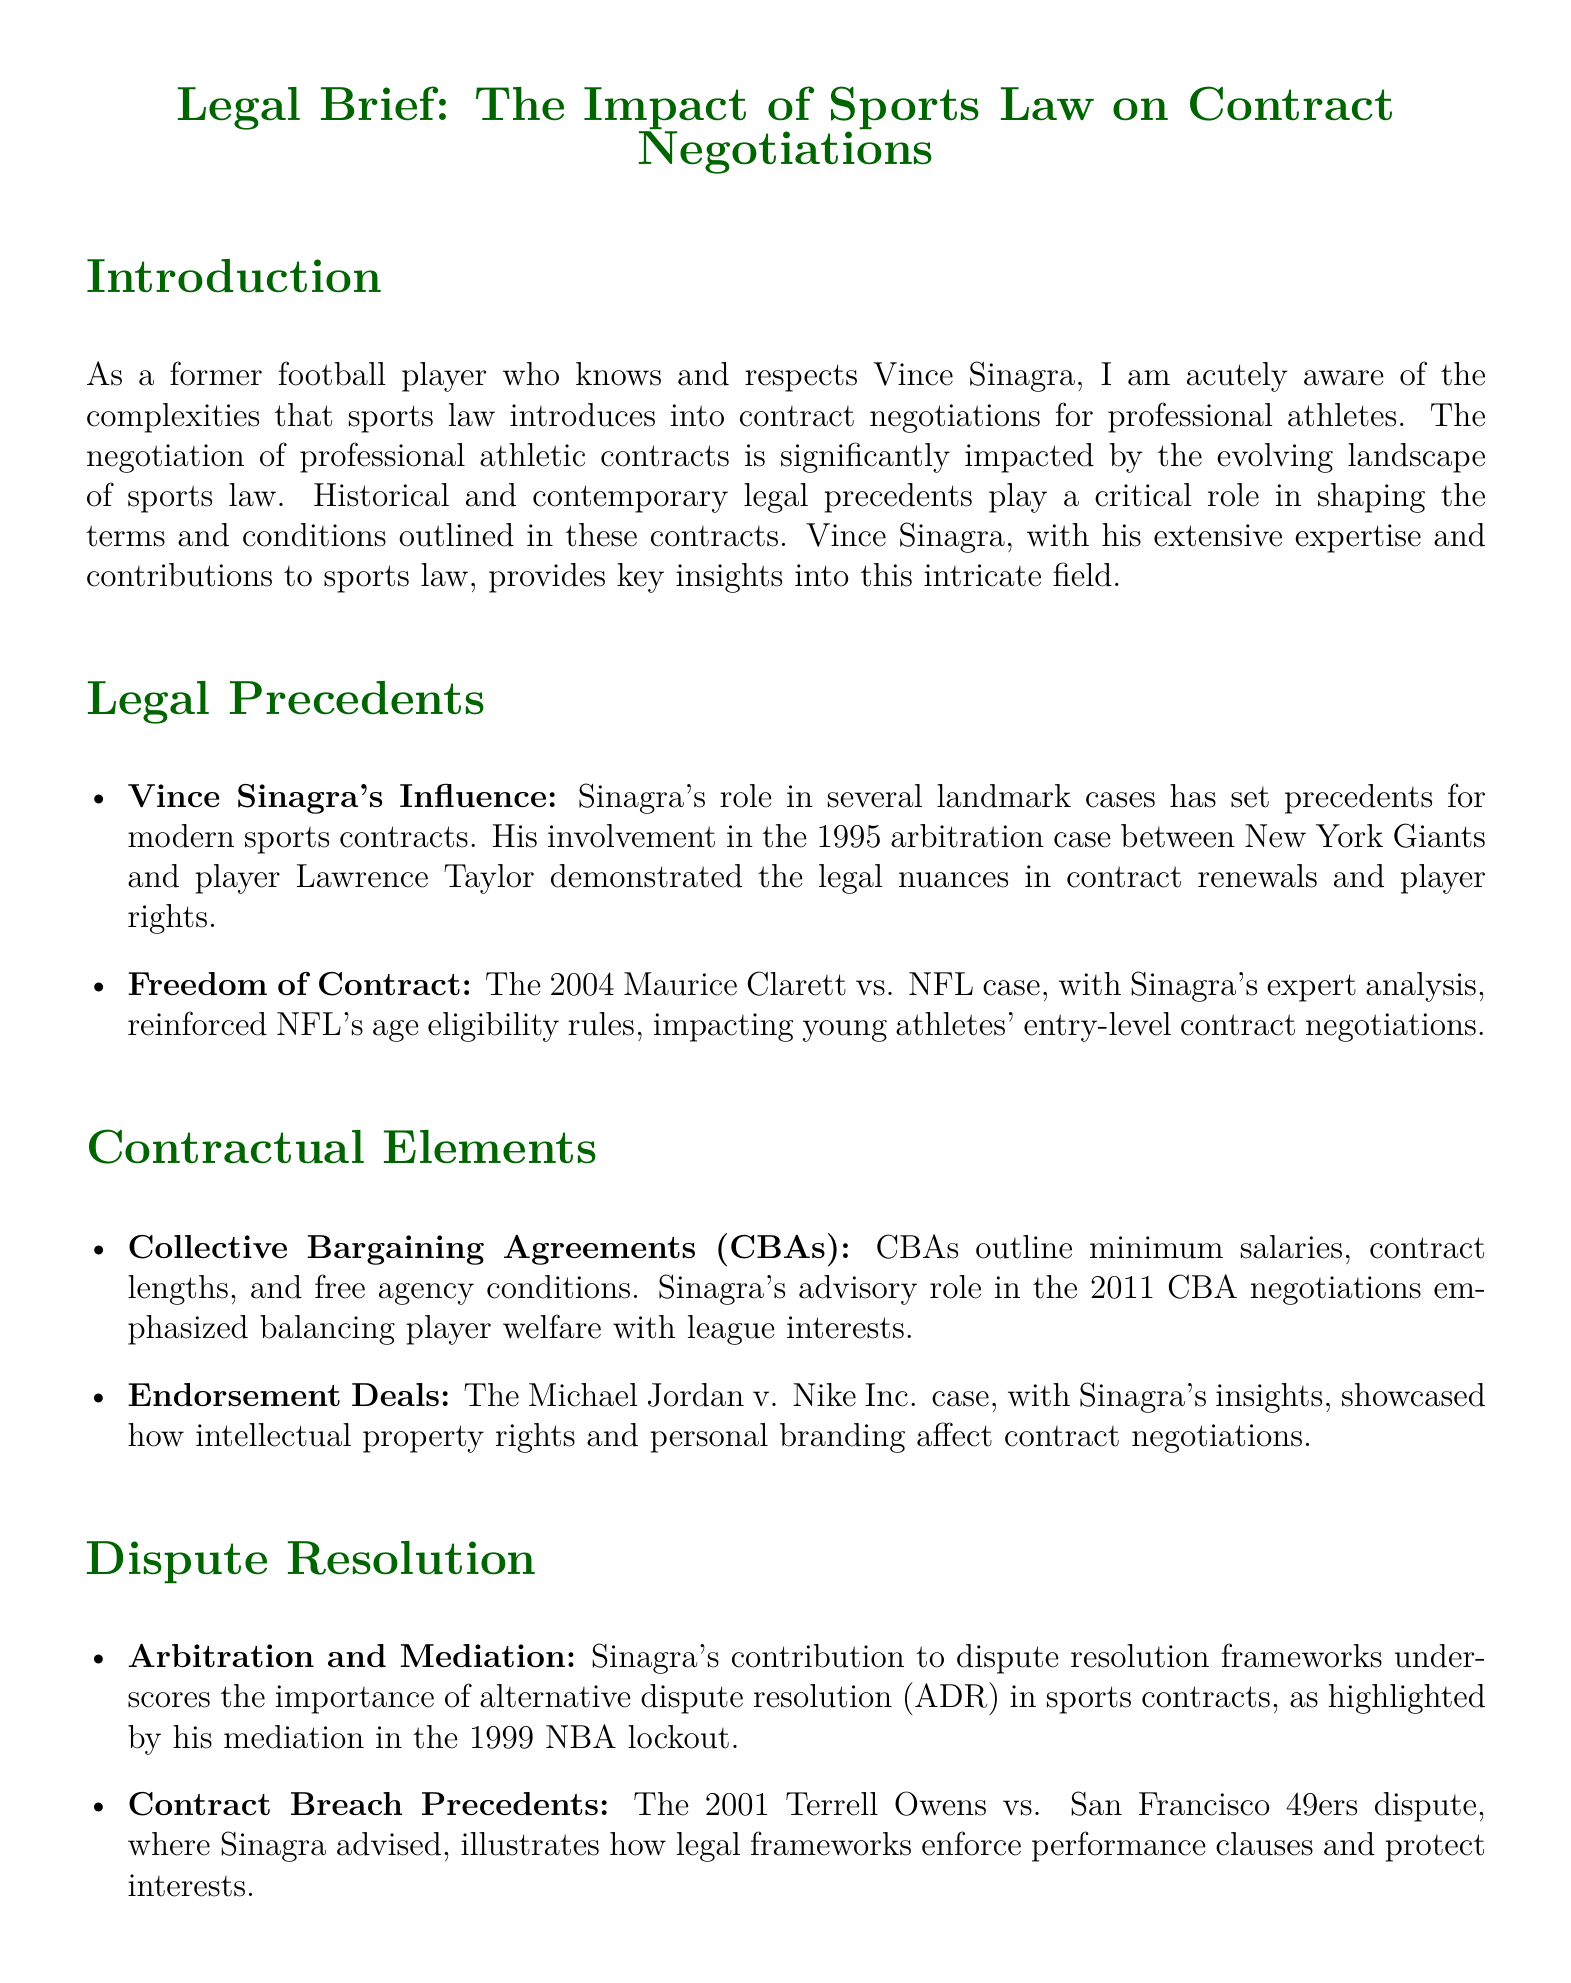What is the title of the document? The title is presented at the top of the document, clearly indicating its subject matter related to sports law.
Answer: Legal Brief: The Impact of Sports Law on Contract Negotiations Who was involved in the 1995 arbitration case? The document states that the case involved the New York Giants and player Lawrence Taylor, highlighting the legal nuances in contract renewals.
Answer: Lawrence Taylor What role did Vince Sinagra play in the 2011 CBA negotiations? The document outlines Sinagra's role as an advisor, emphasizing the balance between player welfare and league interests during negotiations.
Answer: Advisor Which case reinforced NFL's age eligibility rules? The document discusses a specific legal case that played a crucial role in shaping age eligibility for NFL contracts.
Answer: Maurice Clarett vs. NFL What was highlighted by Sinagra's mediation in the 1999 NBA lockout? The document notes the significance of alternative dispute resolution mechanisms in sports contracts.
Answer: Importance of ADR What is emphasized in the section on endorsement deals? The document provides insight into how intellectual property rights and personal branding can influence contract negotiations.
Answer: Intellectual property rights What type of agreement outlines minimum salaries? The document specifically mentions the type of agreements that govern various terms and conditions for athletes' contracts.
Answer: Collective Bargaining Agreements (CBAs) In what year did the Terrell Owens dispute occur? The document includes a specific year indicating when the notable dispute regarding contract breach took place.
Answer: 2001 